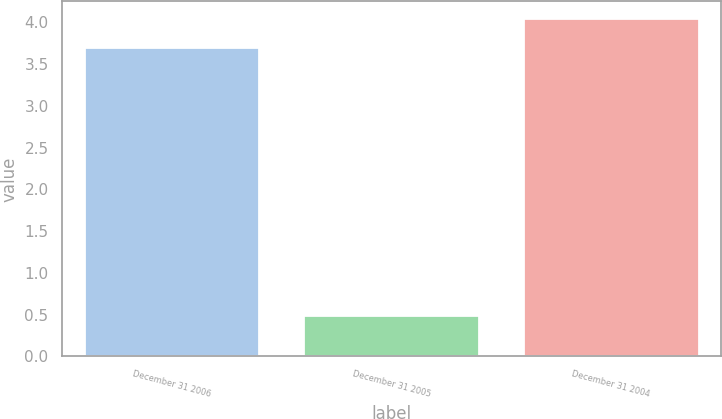<chart> <loc_0><loc_0><loc_500><loc_500><bar_chart><fcel>December 31 2006<fcel>December 31 2005<fcel>December 31 2004<nl><fcel>3.7<fcel>0.5<fcel>4.05<nl></chart> 